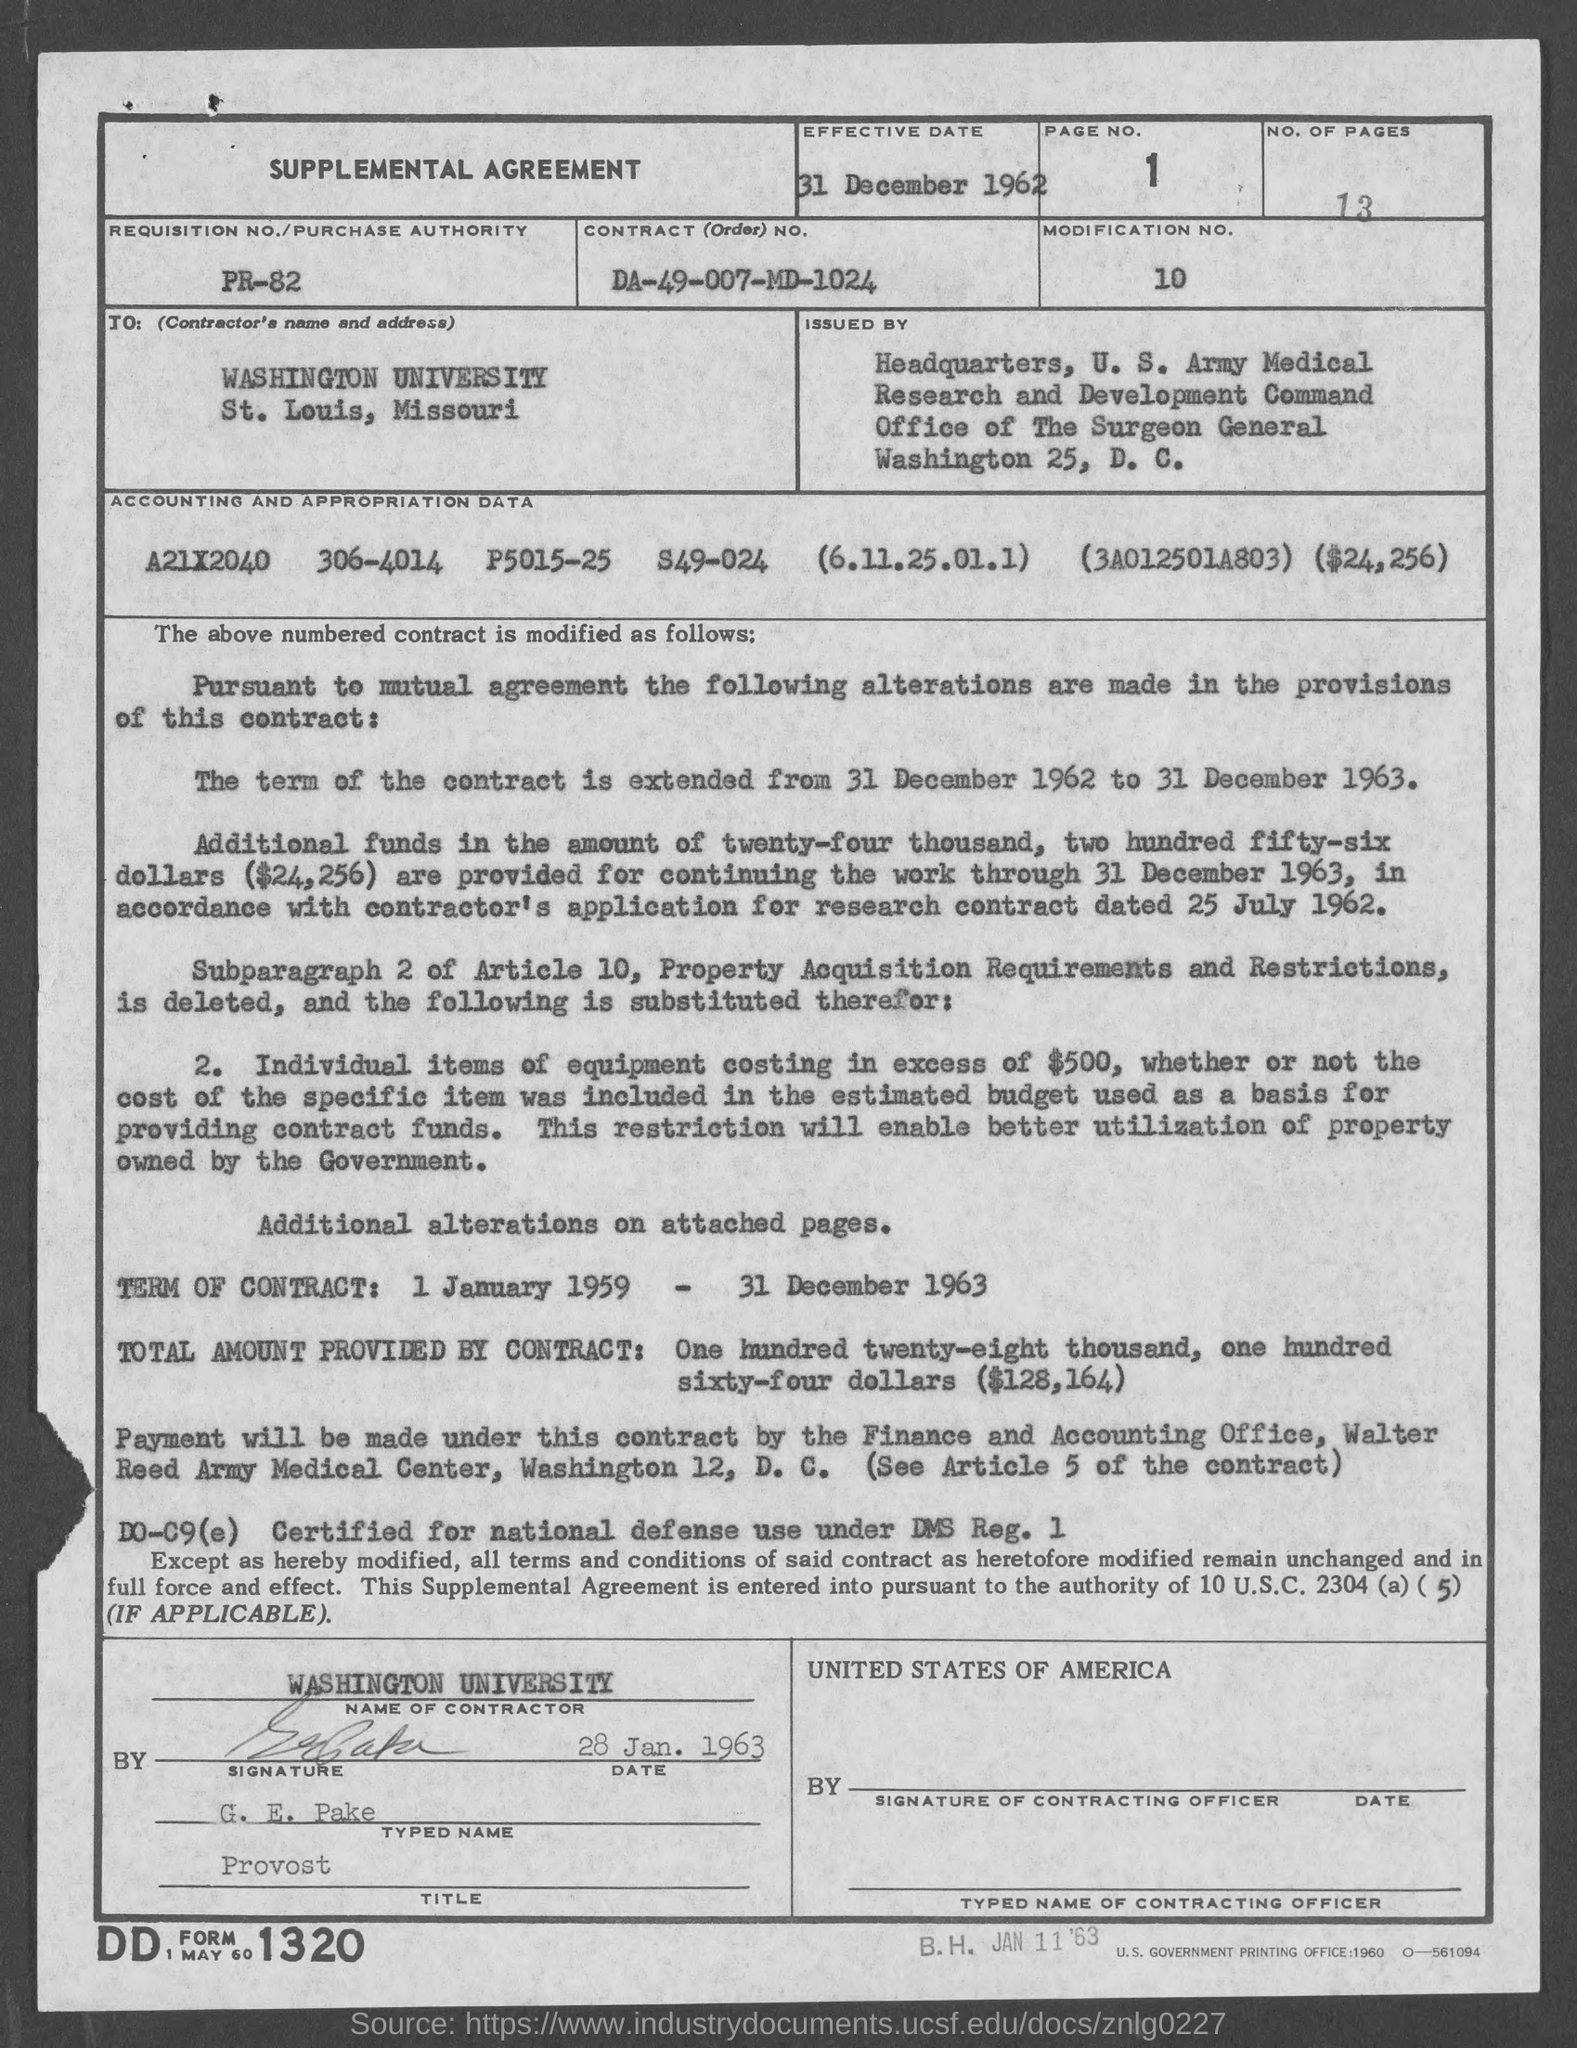What is the total amount provided by the contract as stated in the document? The total amount provided by the contract, as stated in the document, is $128,164, which is outlined in bold in the lower section under 'TOTAL AMOUNT PROVIDED BY CONTRACT.' 